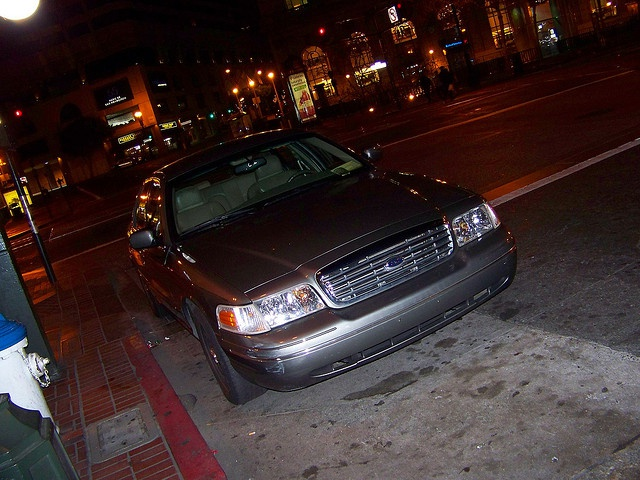Describe the objects in this image and their specific colors. I can see car in white, black, gray, lightgray, and maroon tones and fire hydrant in white, lightgray, blue, navy, and darkgray tones in this image. 